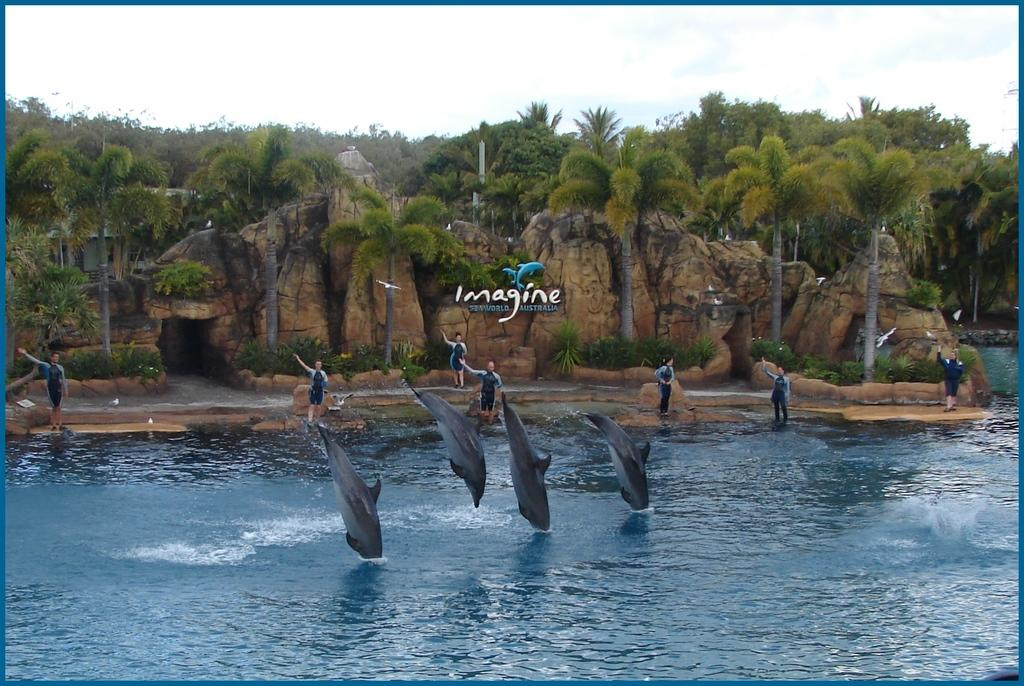What is the primary element in the image? There is water in the image. What animals can be seen in the water? There are dolphins in the water. Are there any people present in the image? Yes, there are people in the image. What can be seen in the background of the image? There is a name board, trees, plants, rocks, a house, and the sky visible in the background of the image. Can you see any dinosaurs in the image? No, there are no dinosaurs present in the image. What type of glove is being used by the people in the image? There is no glove visible in the image. 